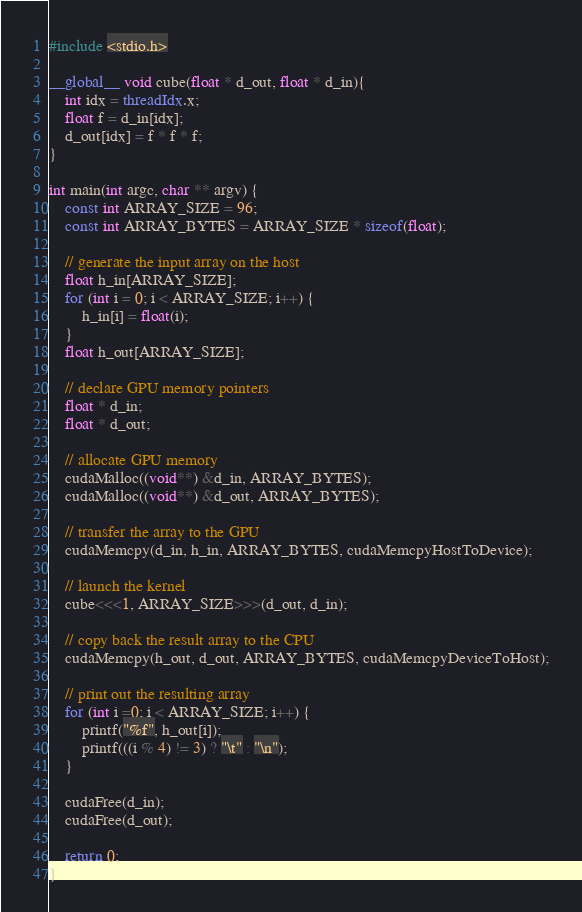Convert code to text. <code><loc_0><loc_0><loc_500><loc_500><_Cuda_>#include <stdio.h>

__global__ void cube(float * d_out, float * d_in){
    int idx = threadIdx.x;
    float f = d_in[idx];
    d_out[idx] = f * f * f;
}

int main(int argc, char ** argv) {
    const int ARRAY_SIZE = 96;
    const int ARRAY_BYTES = ARRAY_SIZE * sizeof(float);

    // generate the input array on the host
    float h_in[ARRAY_SIZE];
    for (int i = 0; i < ARRAY_SIZE; i++) {
        h_in[i] = float(i);
    }
    float h_out[ARRAY_SIZE];

    // declare GPU memory pointers
    float * d_in;
    float * d_out;

    // allocate GPU memory
    cudaMalloc((void**) &d_in, ARRAY_BYTES);
    cudaMalloc((void**) &d_out, ARRAY_BYTES);

    // transfer the array to the GPU
    cudaMemcpy(d_in, h_in, ARRAY_BYTES, cudaMemcpyHostToDevice);

    // launch the kernel
    cube<<<1, ARRAY_SIZE>>>(d_out, d_in);

    // copy back the result array to the CPU
    cudaMemcpy(h_out, d_out, ARRAY_BYTES, cudaMemcpyDeviceToHost);

    // print out the resulting array
    for (int i =0; i < ARRAY_SIZE; i++) {
        printf("%f", h_out[i]);
        printf(((i % 4) != 3) ? "\t" : "\n");
    }

    cudaFree(d_in);
    cudaFree(d_out);

    return 0;
}
</code> 